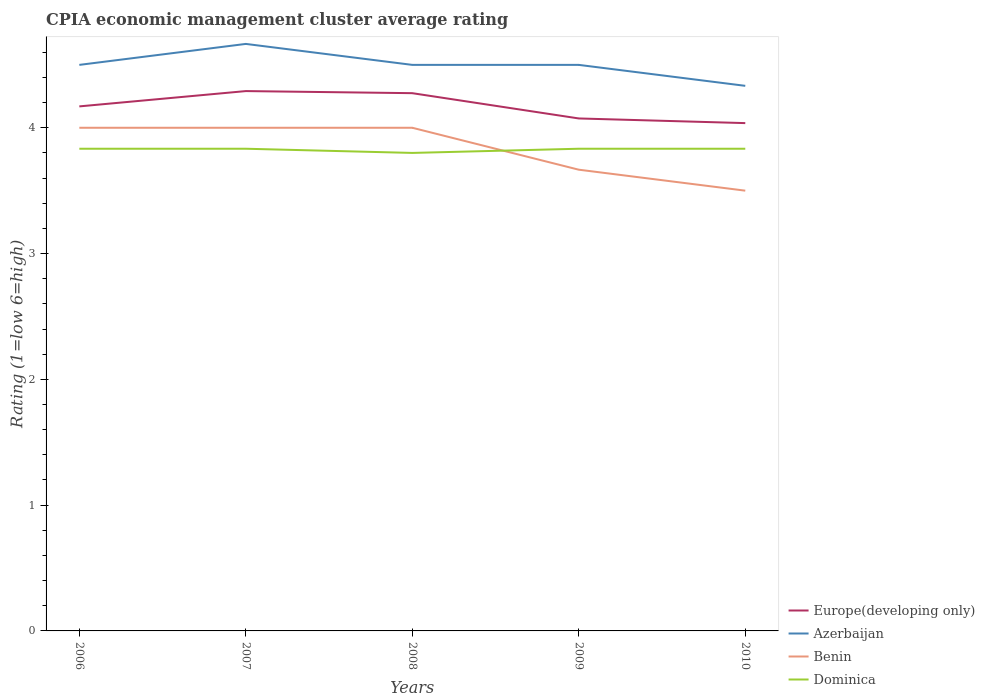How many different coloured lines are there?
Provide a short and direct response. 4. Does the line corresponding to Dominica intersect with the line corresponding to Azerbaijan?
Your answer should be compact. No. What is the total CPIA rating in Dominica in the graph?
Ensure brevity in your answer.  0.03. What is the difference between the highest and the lowest CPIA rating in Benin?
Ensure brevity in your answer.  3. Is the CPIA rating in Dominica strictly greater than the CPIA rating in Azerbaijan over the years?
Give a very brief answer. Yes. What is the difference between two consecutive major ticks on the Y-axis?
Give a very brief answer. 1. Are the values on the major ticks of Y-axis written in scientific E-notation?
Ensure brevity in your answer.  No. Does the graph contain grids?
Offer a very short reply. No. Where does the legend appear in the graph?
Your response must be concise. Bottom right. How are the legend labels stacked?
Offer a terse response. Vertical. What is the title of the graph?
Make the answer very short. CPIA economic management cluster average rating. Does "Belarus" appear as one of the legend labels in the graph?
Offer a terse response. No. What is the label or title of the X-axis?
Give a very brief answer. Years. What is the label or title of the Y-axis?
Your answer should be very brief. Rating (1=low 6=high). What is the Rating (1=low 6=high) in Europe(developing only) in 2006?
Your response must be concise. 4.17. What is the Rating (1=low 6=high) in Benin in 2006?
Provide a short and direct response. 4. What is the Rating (1=low 6=high) of Dominica in 2006?
Provide a succinct answer. 3.83. What is the Rating (1=low 6=high) in Europe(developing only) in 2007?
Ensure brevity in your answer.  4.29. What is the Rating (1=low 6=high) of Azerbaijan in 2007?
Keep it short and to the point. 4.67. What is the Rating (1=low 6=high) in Dominica in 2007?
Your answer should be compact. 3.83. What is the Rating (1=low 6=high) in Europe(developing only) in 2008?
Your answer should be compact. 4.28. What is the Rating (1=low 6=high) in Azerbaijan in 2008?
Your answer should be compact. 4.5. What is the Rating (1=low 6=high) in Dominica in 2008?
Offer a terse response. 3.8. What is the Rating (1=low 6=high) in Europe(developing only) in 2009?
Give a very brief answer. 4.07. What is the Rating (1=low 6=high) of Benin in 2009?
Your answer should be very brief. 3.67. What is the Rating (1=low 6=high) of Dominica in 2009?
Make the answer very short. 3.83. What is the Rating (1=low 6=high) of Europe(developing only) in 2010?
Keep it short and to the point. 4.04. What is the Rating (1=low 6=high) of Azerbaijan in 2010?
Keep it short and to the point. 4.33. What is the Rating (1=low 6=high) of Benin in 2010?
Your answer should be very brief. 3.5. What is the Rating (1=low 6=high) in Dominica in 2010?
Your answer should be compact. 3.83. Across all years, what is the maximum Rating (1=low 6=high) in Europe(developing only)?
Offer a very short reply. 4.29. Across all years, what is the maximum Rating (1=low 6=high) in Azerbaijan?
Your answer should be compact. 4.67. Across all years, what is the maximum Rating (1=low 6=high) in Dominica?
Keep it short and to the point. 3.83. Across all years, what is the minimum Rating (1=low 6=high) in Europe(developing only)?
Ensure brevity in your answer.  4.04. Across all years, what is the minimum Rating (1=low 6=high) of Azerbaijan?
Keep it short and to the point. 4.33. Across all years, what is the minimum Rating (1=low 6=high) of Benin?
Give a very brief answer. 3.5. What is the total Rating (1=low 6=high) in Europe(developing only) in the graph?
Offer a terse response. 20.85. What is the total Rating (1=low 6=high) in Benin in the graph?
Offer a terse response. 19.17. What is the total Rating (1=low 6=high) in Dominica in the graph?
Your response must be concise. 19.13. What is the difference between the Rating (1=low 6=high) of Europe(developing only) in 2006 and that in 2007?
Make the answer very short. -0.12. What is the difference between the Rating (1=low 6=high) of Europe(developing only) in 2006 and that in 2008?
Provide a succinct answer. -0.1. What is the difference between the Rating (1=low 6=high) of Azerbaijan in 2006 and that in 2008?
Offer a very short reply. 0. What is the difference between the Rating (1=low 6=high) in Europe(developing only) in 2006 and that in 2009?
Provide a succinct answer. 0.1. What is the difference between the Rating (1=low 6=high) in Dominica in 2006 and that in 2009?
Make the answer very short. 0. What is the difference between the Rating (1=low 6=high) in Europe(developing only) in 2006 and that in 2010?
Make the answer very short. 0.13. What is the difference between the Rating (1=low 6=high) of Benin in 2006 and that in 2010?
Your response must be concise. 0.5. What is the difference between the Rating (1=low 6=high) of Dominica in 2006 and that in 2010?
Your answer should be very brief. 0. What is the difference between the Rating (1=low 6=high) of Europe(developing only) in 2007 and that in 2008?
Offer a terse response. 0.02. What is the difference between the Rating (1=low 6=high) in Dominica in 2007 and that in 2008?
Offer a terse response. 0.03. What is the difference between the Rating (1=low 6=high) of Europe(developing only) in 2007 and that in 2009?
Your answer should be very brief. 0.22. What is the difference between the Rating (1=low 6=high) in Azerbaijan in 2007 and that in 2009?
Offer a very short reply. 0.17. What is the difference between the Rating (1=low 6=high) in Dominica in 2007 and that in 2009?
Provide a succinct answer. 0. What is the difference between the Rating (1=low 6=high) in Europe(developing only) in 2007 and that in 2010?
Ensure brevity in your answer.  0.25. What is the difference between the Rating (1=low 6=high) of Benin in 2007 and that in 2010?
Your answer should be compact. 0.5. What is the difference between the Rating (1=low 6=high) of Dominica in 2007 and that in 2010?
Provide a short and direct response. 0. What is the difference between the Rating (1=low 6=high) of Europe(developing only) in 2008 and that in 2009?
Offer a terse response. 0.2. What is the difference between the Rating (1=low 6=high) of Azerbaijan in 2008 and that in 2009?
Your response must be concise. 0. What is the difference between the Rating (1=low 6=high) of Benin in 2008 and that in 2009?
Provide a succinct answer. 0.33. What is the difference between the Rating (1=low 6=high) in Dominica in 2008 and that in 2009?
Your answer should be compact. -0.03. What is the difference between the Rating (1=low 6=high) of Europe(developing only) in 2008 and that in 2010?
Your response must be concise. 0.24. What is the difference between the Rating (1=low 6=high) in Dominica in 2008 and that in 2010?
Give a very brief answer. -0.03. What is the difference between the Rating (1=low 6=high) of Europe(developing only) in 2009 and that in 2010?
Make the answer very short. 0.04. What is the difference between the Rating (1=low 6=high) of Azerbaijan in 2009 and that in 2010?
Provide a succinct answer. 0.17. What is the difference between the Rating (1=low 6=high) in Dominica in 2009 and that in 2010?
Your answer should be compact. 0. What is the difference between the Rating (1=low 6=high) in Europe(developing only) in 2006 and the Rating (1=low 6=high) in Azerbaijan in 2007?
Ensure brevity in your answer.  -0.5. What is the difference between the Rating (1=low 6=high) of Europe(developing only) in 2006 and the Rating (1=low 6=high) of Benin in 2007?
Your answer should be compact. 0.17. What is the difference between the Rating (1=low 6=high) in Europe(developing only) in 2006 and the Rating (1=low 6=high) in Dominica in 2007?
Provide a succinct answer. 0.34. What is the difference between the Rating (1=low 6=high) of Azerbaijan in 2006 and the Rating (1=low 6=high) of Dominica in 2007?
Provide a succinct answer. 0.67. What is the difference between the Rating (1=low 6=high) of Europe(developing only) in 2006 and the Rating (1=low 6=high) of Azerbaijan in 2008?
Offer a very short reply. -0.33. What is the difference between the Rating (1=low 6=high) of Europe(developing only) in 2006 and the Rating (1=low 6=high) of Benin in 2008?
Offer a terse response. 0.17. What is the difference between the Rating (1=low 6=high) of Europe(developing only) in 2006 and the Rating (1=low 6=high) of Dominica in 2008?
Offer a very short reply. 0.37. What is the difference between the Rating (1=low 6=high) in Europe(developing only) in 2006 and the Rating (1=low 6=high) in Azerbaijan in 2009?
Ensure brevity in your answer.  -0.33. What is the difference between the Rating (1=low 6=high) of Europe(developing only) in 2006 and the Rating (1=low 6=high) of Benin in 2009?
Provide a succinct answer. 0.5. What is the difference between the Rating (1=low 6=high) of Europe(developing only) in 2006 and the Rating (1=low 6=high) of Dominica in 2009?
Give a very brief answer. 0.34. What is the difference between the Rating (1=low 6=high) in Azerbaijan in 2006 and the Rating (1=low 6=high) in Benin in 2009?
Offer a very short reply. 0.83. What is the difference between the Rating (1=low 6=high) of Benin in 2006 and the Rating (1=low 6=high) of Dominica in 2009?
Provide a succinct answer. 0.17. What is the difference between the Rating (1=low 6=high) of Europe(developing only) in 2006 and the Rating (1=low 6=high) of Azerbaijan in 2010?
Your answer should be very brief. -0.16. What is the difference between the Rating (1=low 6=high) of Europe(developing only) in 2006 and the Rating (1=low 6=high) of Benin in 2010?
Make the answer very short. 0.67. What is the difference between the Rating (1=low 6=high) in Europe(developing only) in 2006 and the Rating (1=low 6=high) in Dominica in 2010?
Offer a very short reply. 0.34. What is the difference between the Rating (1=low 6=high) of Azerbaijan in 2006 and the Rating (1=low 6=high) of Benin in 2010?
Provide a succinct answer. 1. What is the difference between the Rating (1=low 6=high) of Europe(developing only) in 2007 and the Rating (1=low 6=high) of Azerbaijan in 2008?
Provide a succinct answer. -0.21. What is the difference between the Rating (1=low 6=high) of Europe(developing only) in 2007 and the Rating (1=low 6=high) of Benin in 2008?
Make the answer very short. 0.29. What is the difference between the Rating (1=low 6=high) of Europe(developing only) in 2007 and the Rating (1=low 6=high) of Dominica in 2008?
Offer a terse response. 0.49. What is the difference between the Rating (1=low 6=high) of Azerbaijan in 2007 and the Rating (1=low 6=high) of Benin in 2008?
Keep it short and to the point. 0.67. What is the difference between the Rating (1=low 6=high) of Azerbaijan in 2007 and the Rating (1=low 6=high) of Dominica in 2008?
Provide a succinct answer. 0.87. What is the difference between the Rating (1=low 6=high) in Benin in 2007 and the Rating (1=low 6=high) in Dominica in 2008?
Ensure brevity in your answer.  0.2. What is the difference between the Rating (1=low 6=high) in Europe(developing only) in 2007 and the Rating (1=low 6=high) in Azerbaijan in 2009?
Make the answer very short. -0.21. What is the difference between the Rating (1=low 6=high) in Europe(developing only) in 2007 and the Rating (1=low 6=high) in Dominica in 2009?
Offer a terse response. 0.46. What is the difference between the Rating (1=low 6=high) of Azerbaijan in 2007 and the Rating (1=low 6=high) of Benin in 2009?
Ensure brevity in your answer.  1. What is the difference between the Rating (1=low 6=high) of Azerbaijan in 2007 and the Rating (1=low 6=high) of Dominica in 2009?
Provide a short and direct response. 0.83. What is the difference between the Rating (1=low 6=high) of Benin in 2007 and the Rating (1=low 6=high) of Dominica in 2009?
Keep it short and to the point. 0.17. What is the difference between the Rating (1=low 6=high) in Europe(developing only) in 2007 and the Rating (1=low 6=high) in Azerbaijan in 2010?
Make the answer very short. -0.04. What is the difference between the Rating (1=low 6=high) of Europe(developing only) in 2007 and the Rating (1=low 6=high) of Benin in 2010?
Offer a terse response. 0.79. What is the difference between the Rating (1=low 6=high) of Europe(developing only) in 2007 and the Rating (1=low 6=high) of Dominica in 2010?
Offer a terse response. 0.46. What is the difference between the Rating (1=low 6=high) in Azerbaijan in 2007 and the Rating (1=low 6=high) in Dominica in 2010?
Make the answer very short. 0.83. What is the difference between the Rating (1=low 6=high) of Europe(developing only) in 2008 and the Rating (1=low 6=high) of Azerbaijan in 2009?
Your response must be concise. -0.23. What is the difference between the Rating (1=low 6=high) in Europe(developing only) in 2008 and the Rating (1=low 6=high) in Benin in 2009?
Ensure brevity in your answer.  0.61. What is the difference between the Rating (1=low 6=high) of Europe(developing only) in 2008 and the Rating (1=low 6=high) of Dominica in 2009?
Your answer should be very brief. 0.44. What is the difference between the Rating (1=low 6=high) of Europe(developing only) in 2008 and the Rating (1=low 6=high) of Azerbaijan in 2010?
Your response must be concise. -0.06. What is the difference between the Rating (1=low 6=high) of Europe(developing only) in 2008 and the Rating (1=low 6=high) of Benin in 2010?
Keep it short and to the point. 0.78. What is the difference between the Rating (1=low 6=high) of Europe(developing only) in 2008 and the Rating (1=low 6=high) of Dominica in 2010?
Ensure brevity in your answer.  0.44. What is the difference between the Rating (1=low 6=high) in Europe(developing only) in 2009 and the Rating (1=low 6=high) in Azerbaijan in 2010?
Give a very brief answer. -0.26. What is the difference between the Rating (1=low 6=high) in Europe(developing only) in 2009 and the Rating (1=low 6=high) in Benin in 2010?
Ensure brevity in your answer.  0.57. What is the difference between the Rating (1=low 6=high) of Europe(developing only) in 2009 and the Rating (1=low 6=high) of Dominica in 2010?
Make the answer very short. 0.24. What is the difference between the Rating (1=low 6=high) in Benin in 2009 and the Rating (1=low 6=high) in Dominica in 2010?
Give a very brief answer. -0.17. What is the average Rating (1=low 6=high) of Europe(developing only) per year?
Provide a succinct answer. 4.17. What is the average Rating (1=low 6=high) of Benin per year?
Make the answer very short. 3.83. What is the average Rating (1=low 6=high) in Dominica per year?
Offer a terse response. 3.83. In the year 2006, what is the difference between the Rating (1=low 6=high) of Europe(developing only) and Rating (1=low 6=high) of Azerbaijan?
Ensure brevity in your answer.  -0.33. In the year 2006, what is the difference between the Rating (1=low 6=high) in Europe(developing only) and Rating (1=low 6=high) in Benin?
Your answer should be compact. 0.17. In the year 2006, what is the difference between the Rating (1=low 6=high) in Europe(developing only) and Rating (1=low 6=high) in Dominica?
Provide a short and direct response. 0.34. In the year 2006, what is the difference between the Rating (1=low 6=high) in Azerbaijan and Rating (1=low 6=high) in Benin?
Your answer should be very brief. 0.5. In the year 2006, what is the difference between the Rating (1=low 6=high) of Benin and Rating (1=low 6=high) of Dominica?
Give a very brief answer. 0.17. In the year 2007, what is the difference between the Rating (1=low 6=high) of Europe(developing only) and Rating (1=low 6=high) of Azerbaijan?
Your answer should be compact. -0.38. In the year 2007, what is the difference between the Rating (1=low 6=high) in Europe(developing only) and Rating (1=low 6=high) in Benin?
Provide a short and direct response. 0.29. In the year 2007, what is the difference between the Rating (1=low 6=high) in Europe(developing only) and Rating (1=low 6=high) in Dominica?
Give a very brief answer. 0.46. In the year 2007, what is the difference between the Rating (1=low 6=high) of Azerbaijan and Rating (1=low 6=high) of Benin?
Ensure brevity in your answer.  0.67. In the year 2007, what is the difference between the Rating (1=low 6=high) of Azerbaijan and Rating (1=low 6=high) of Dominica?
Offer a very short reply. 0.83. In the year 2007, what is the difference between the Rating (1=low 6=high) of Benin and Rating (1=low 6=high) of Dominica?
Your answer should be very brief. 0.17. In the year 2008, what is the difference between the Rating (1=low 6=high) of Europe(developing only) and Rating (1=low 6=high) of Azerbaijan?
Offer a terse response. -0.23. In the year 2008, what is the difference between the Rating (1=low 6=high) of Europe(developing only) and Rating (1=low 6=high) of Benin?
Offer a terse response. 0.28. In the year 2008, what is the difference between the Rating (1=low 6=high) in Europe(developing only) and Rating (1=low 6=high) in Dominica?
Offer a terse response. 0.47. In the year 2008, what is the difference between the Rating (1=low 6=high) of Azerbaijan and Rating (1=low 6=high) of Dominica?
Ensure brevity in your answer.  0.7. In the year 2009, what is the difference between the Rating (1=low 6=high) of Europe(developing only) and Rating (1=low 6=high) of Azerbaijan?
Provide a short and direct response. -0.43. In the year 2009, what is the difference between the Rating (1=low 6=high) in Europe(developing only) and Rating (1=low 6=high) in Benin?
Keep it short and to the point. 0.41. In the year 2009, what is the difference between the Rating (1=low 6=high) of Europe(developing only) and Rating (1=low 6=high) of Dominica?
Provide a succinct answer. 0.24. In the year 2010, what is the difference between the Rating (1=low 6=high) in Europe(developing only) and Rating (1=low 6=high) in Azerbaijan?
Provide a succinct answer. -0.3. In the year 2010, what is the difference between the Rating (1=low 6=high) in Europe(developing only) and Rating (1=low 6=high) in Benin?
Offer a very short reply. 0.54. In the year 2010, what is the difference between the Rating (1=low 6=high) of Europe(developing only) and Rating (1=low 6=high) of Dominica?
Give a very brief answer. 0.2. What is the ratio of the Rating (1=low 6=high) in Europe(developing only) in 2006 to that in 2007?
Provide a succinct answer. 0.97. What is the ratio of the Rating (1=low 6=high) of Azerbaijan in 2006 to that in 2007?
Provide a succinct answer. 0.96. What is the ratio of the Rating (1=low 6=high) of Europe(developing only) in 2006 to that in 2008?
Give a very brief answer. 0.98. What is the ratio of the Rating (1=low 6=high) of Benin in 2006 to that in 2008?
Make the answer very short. 1. What is the ratio of the Rating (1=low 6=high) in Dominica in 2006 to that in 2008?
Ensure brevity in your answer.  1.01. What is the ratio of the Rating (1=low 6=high) in Europe(developing only) in 2006 to that in 2009?
Ensure brevity in your answer.  1.02. What is the ratio of the Rating (1=low 6=high) in Benin in 2006 to that in 2009?
Your answer should be very brief. 1.09. What is the ratio of the Rating (1=low 6=high) in Dominica in 2006 to that in 2009?
Your answer should be compact. 1. What is the ratio of the Rating (1=low 6=high) in Europe(developing only) in 2006 to that in 2010?
Keep it short and to the point. 1.03. What is the ratio of the Rating (1=low 6=high) of Azerbaijan in 2006 to that in 2010?
Your answer should be compact. 1.04. What is the ratio of the Rating (1=low 6=high) in Benin in 2006 to that in 2010?
Keep it short and to the point. 1.14. What is the ratio of the Rating (1=low 6=high) of Dominica in 2006 to that in 2010?
Provide a succinct answer. 1. What is the ratio of the Rating (1=low 6=high) in Azerbaijan in 2007 to that in 2008?
Your response must be concise. 1.04. What is the ratio of the Rating (1=low 6=high) in Dominica in 2007 to that in 2008?
Your answer should be very brief. 1.01. What is the ratio of the Rating (1=low 6=high) of Europe(developing only) in 2007 to that in 2009?
Give a very brief answer. 1.05. What is the ratio of the Rating (1=low 6=high) of Europe(developing only) in 2007 to that in 2010?
Offer a very short reply. 1.06. What is the ratio of the Rating (1=low 6=high) of Benin in 2007 to that in 2010?
Provide a short and direct response. 1.14. What is the ratio of the Rating (1=low 6=high) of Dominica in 2007 to that in 2010?
Give a very brief answer. 1. What is the ratio of the Rating (1=low 6=high) of Europe(developing only) in 2008 to that in 2009?
Your answer should be very brief. 1.05. What is the ratio of the Rating (1=low 6=high) of Dominica in 2008 to that in 2009?
Your answer should be compact. 0.99. What is the ratio of the Rating (1=low 6=high) of Europe(developing only) in 2008 to that in 2010?
Your response must be concise. 1.06. What is the ratio of the Rating (1=low 6=high) in Azerbaijan in 2008 to that in 2010?
Make the answer very short. 1.04. What is the ratio of the Rating (1=low 6=high) of Benin in 2008 to that in 2010?
Your answer should be compact. 1.14. What is the ratio of the Rating (1=low 6=high) in Europe(developing only) in 2009 to that in 2010?
Make the answer very short. 1.01. What is the ratio of the Rating (1=low 6=high) in Benin in 2009 to that in 2010?
Make the answer very short. 1.05. What is the ratio of the Rating (1=low 6=high) in Dominica in 2009 to that in 2010?
Offer a very short reply. 1. What is the difference between the highest and the second highest Rating (1=low 6=high) of Europe(developing only)?
Your answer should be compact. 0.02. What is the difference between the highest and the second highest Rating (1=low 6=high) of Azerbaijan?
Your response must be concise. 0.17. What is the difference between the highest and the second highest Rating (1=low 6=high) of Benin?
Provide a succinct answer. 0. What is the difference between the highest and the second highest Rating (1=low 6=high) in Dominica?
Provide a succinct answer. 0. What is the difference between the highest and the lowest Rating (1=low 6=high) in Europe(developing only)?
Provide a succinct answer. 0.25. What is the difference between the highest and the lowest Rating (1=low 6=high) in Azerbaijan?
Keep it short and to the point. 0.33. What is the difference between the highest and the lowest Rating (1=low 6=high) in Benin?
Your answer should be compact. 0.5. What is the difference between the highest and the lowest Rating (1=low 6=high) of Dominica?
Keep it short and to the point. 0.03. 